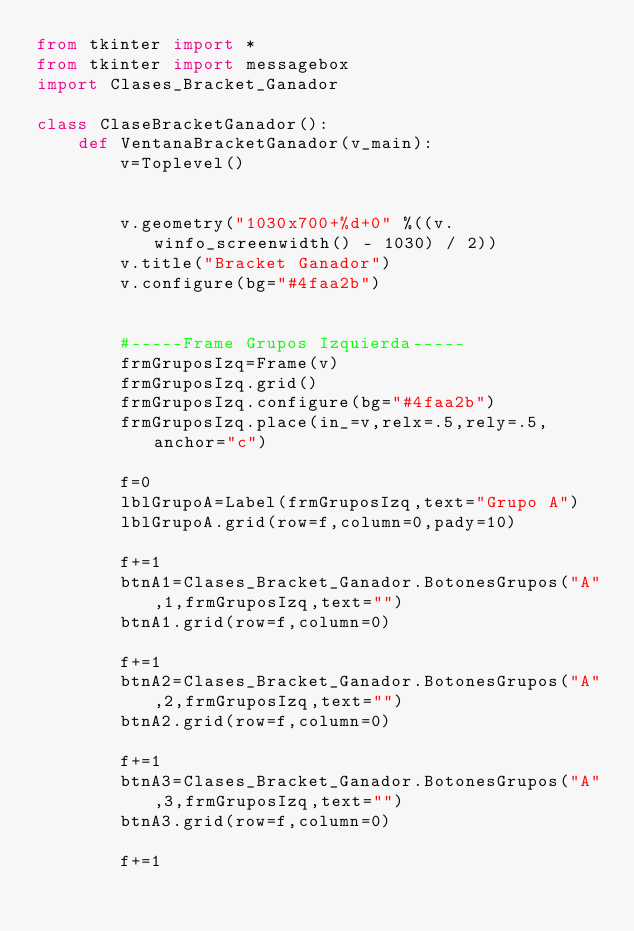Convert code to text. <code><loc_0><loc_0><loc_500><loc_500><_Python_>from tkinter import *
from tkinter import messagebox
import Clases_Bracket_Ganador

class ClaseBracketGanador():
    def VentanaBracketGanador(v_main):
        v=Toplevel()

        
        v.geometry("1030x700+%d+0" %((v.winfo_screenwidth() - 1030) / 2))
        v.title("Bracket Ganador")
        v.configure(bg="#4faa2b")
        
        
        #-----Frame Grupos Izquierda-----
        frmGruposIzq=Frame(v)
        frmGruposIzq.grid()
        frmGruposIzq.configure(bg="#4faa2b")
        frmGruposIzq.place(in_=v,relx=.5,rely=.5,anchor="c")

        f=0
        lblGrupoA=Label(frmGruposIzq,text="Grupo A")
        lblGrupoA.grid(row=f,column=0,pady=10)

        f+=1
        btnA1=Clases_Bracket_Ganador.BotonesGrupos("A",1,frmGruposIzq,text="")
        btnA1.grid(row=f,column=0)

        f+=1
        btnA2=Clases_Bracket_Ganador.BotonesGrupos("A",2,frmGruposIzq,text="")
        btnA2.grid(row=f,column=0)

        f+=1
        btnA3=Clases_Bracket_Ganador.BotonesGrupos("A",3,frmGruposIzq,text="")
        btnA3.grid(row=f,column=0)

        f+=1</code> 